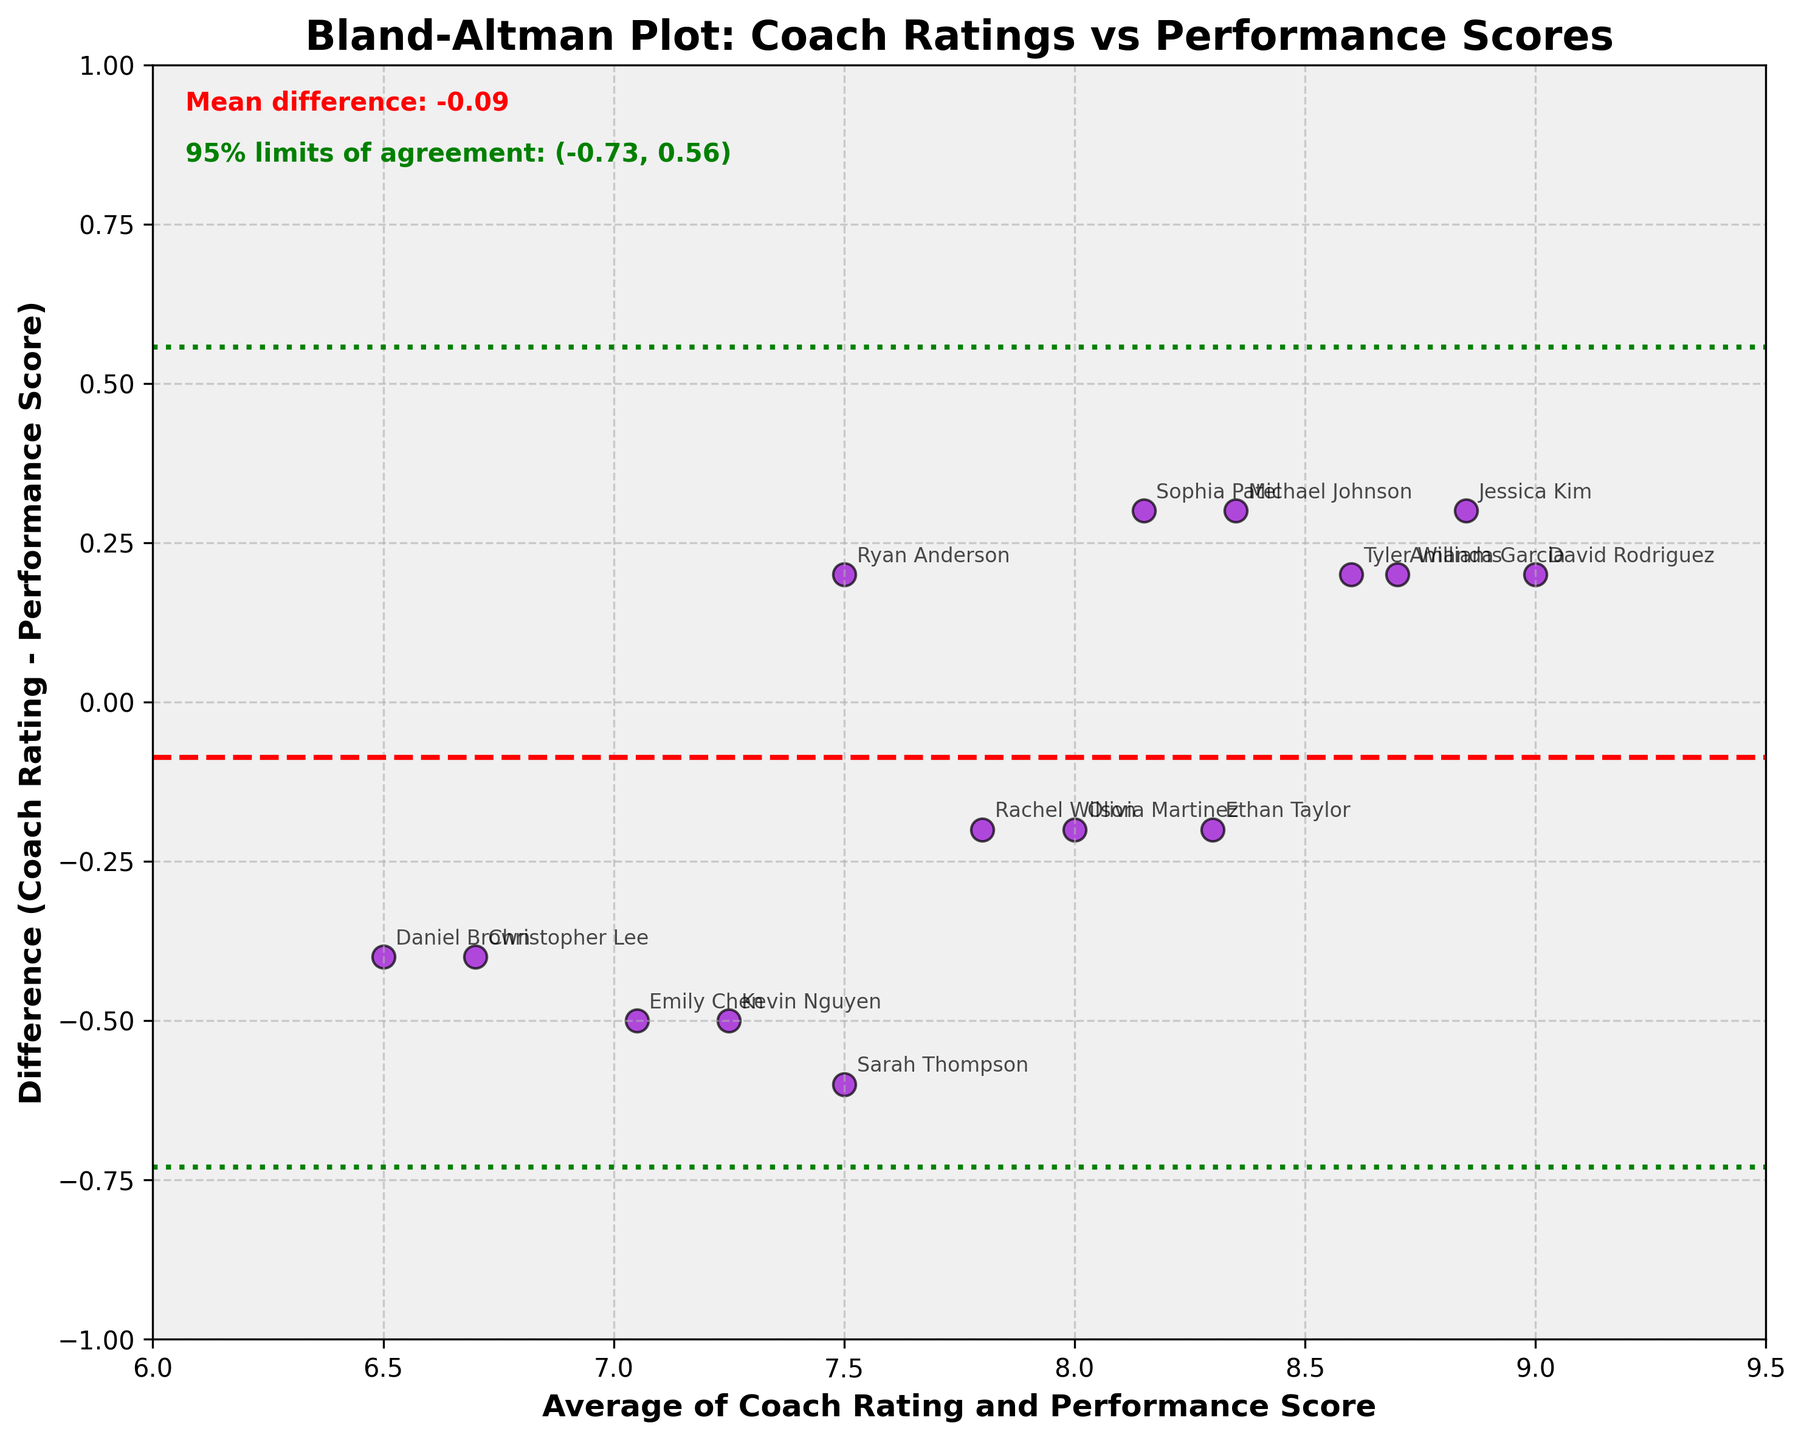what is the title of the plot? The title of the plot is written at the top of the figure. It reads "Bland-Altman Plot: Coach Ratings vs Performance Scores."
Answer: Bland-Altman Plot: Coach Ratings vs Performance Scores What does the red dashed horizontal line represent? The red dashed horizontal line represents the mean difference between the coach ratings and performance scores, which is labeled in the figure.
Answer: Mean difference What are the two green dotted horizontal lines? The green dotted horizontal lines represent the 95% limits of agreement, calculated as the mean difference ± 1.96 times the standard deviation of the differences. These limits are labeled in the figure.
Answer: 95% limits of agreement What is the range of the x-axis in this plot? The x-axis range can be observed from the plotted figure, which spans from 6 to 9.5, as indicated by the tick marks.
Answer: 6 to 9.5 How many players have a positive difference between their coach rating and performance score? To determine this, we count the data points located above the 0 line on the y-axis. There are 7 players with positive differences: Michael Johnson, David Rodriguez, Tyler Williams, Sophia Patel, Ryan Anderson, Jessica Kim, and Amanda Garcia.
Answer: 7 What can you say about the consistency of the ratings by the coach compared to the performance scores? The plot shows that most differences between the coach ratings and performance scores are within the green lines (95% limits of agreement), indicating that the coach ratings are consistently close to the performance scores.
Answer: Consistent Are there any players who have a difference greater than 0.5 or less than -0.5? By examining the plot, no players are above 0.5 but three players, Sarah Thompson, Emily Chen, and Kevin Nguyen, have differences of -0.6 and -0.5, respectively.
Answer: Three players: Sarah Thompson, Emily Chen, and Kevin Nguyen Which player has the largest negative difference, and what is that value? To find the largest negative difference, we look at the lowest point on the plot. Sarah Thompson has the largest negative difference of -0.6.
Answer: Sarah Thompson, -0.6 Which player's rating is closest to the mean difference of the plot? By examining the plot, the player closest to the mean difference (red dashed line) is Ethan Taylor with a difference of -0.2, very close to 0.04 (mean difference).
Answer: Ethan Taylor 